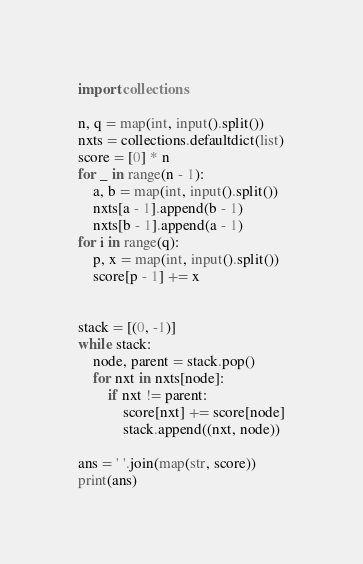Convert code to text. <code><loc_0><loc_0><loc_500><loc_500><_Python_>import collections

n, q = map(int, input().split())
nxts = collections.defaultdict(list)
score = [0] * n 
for _ in range(n - 1):
    a, b = map(int, input().split())
    nxts[a - 1].append(b - 1)
    nxts[b - 1].append(a - 1)
for i in range(q):
    p, x = map(int, input().split())
    score[p - 1] += x


stack = [(0, -1)]
while stack:
    node, parent = stack.pop()
    for nxt in nxts[node]:
        if nxt != parent:
            score[nxt] += score[node]
            stack.append((nxt, node))

ans = ' '.join(map(str, score))
print(ans)
</code> 